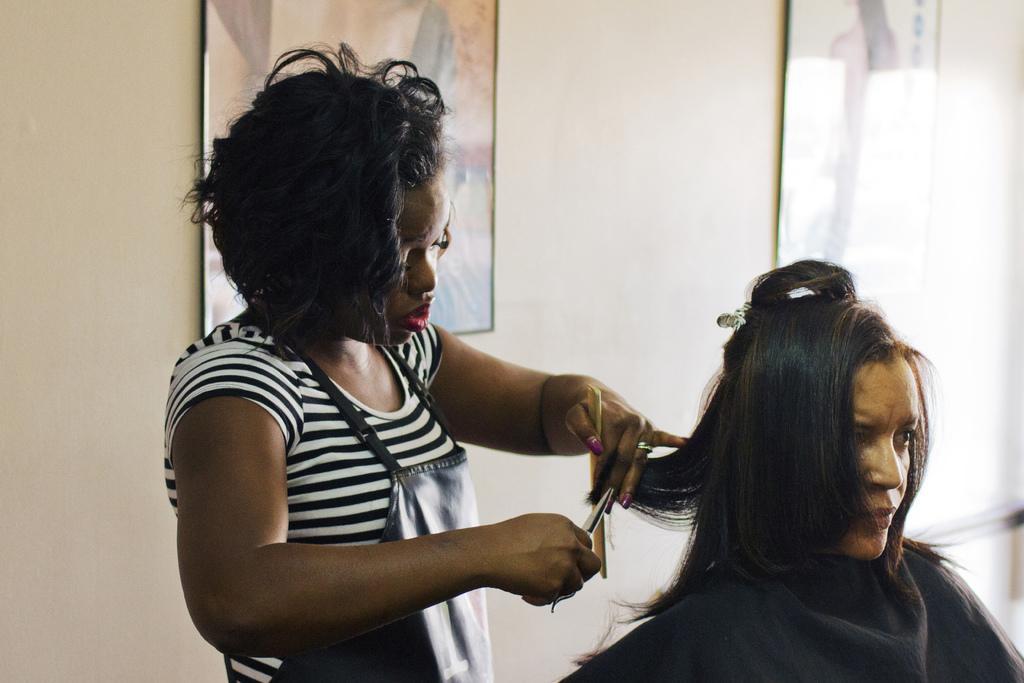In one or two sentences, can you explain what this image depicts? In this image we can see a woman holding a comb and a scissor and cutting the hair of other woman sitting on a chair and in the background there is a wall with picture frames. 